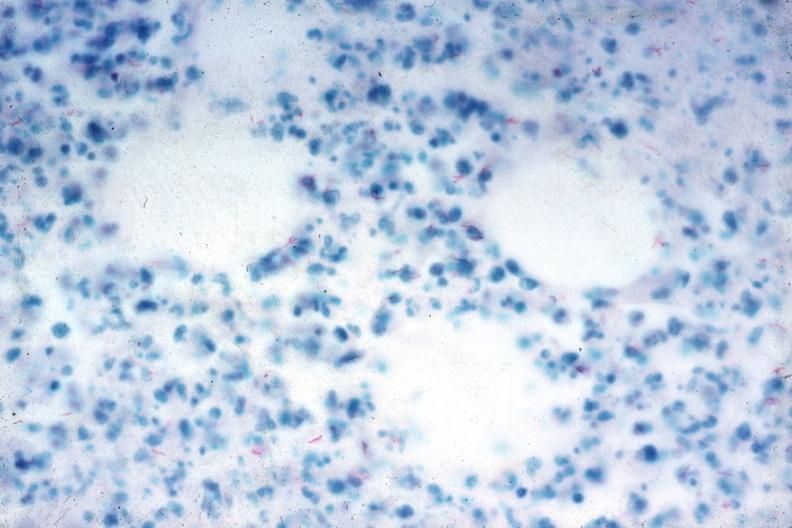what fast stain numerous acid fast bacilli very good slide?
Answer the question using a single word or phrase. Acid 